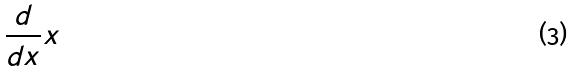Convert formula to latex. <formula><loc_0><loc_0><loc_500><loc_500>\frac { d } { d x } x</formula> 